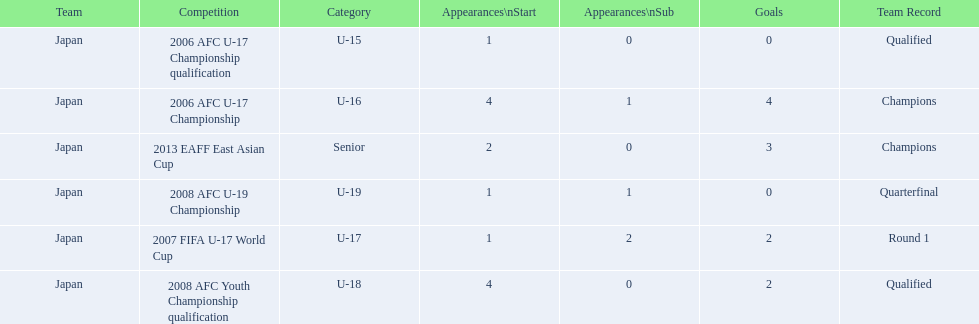What competitions did japan compete in with yoichiro kakitani? 2006 AFC U-17 Championship qualification, 2006 AFC U-17 Championship, 2007 FIFA U-17 World Cup, 2008 AFC Youth Championship qualification, 2008 AFC U-19 Championship, 2013 EAFF East Asian Cup. Of those competitions, which were held in 2007 and 2013? 2007 FIFA U-17 World Cup, 2013 EAFF East Asian Cup. Of the 2007 fifa u-17 world cup and the 2013 eaff east asian cup, which did japan have the most starting appearances? 2013 EAFF East Asian Cup. 